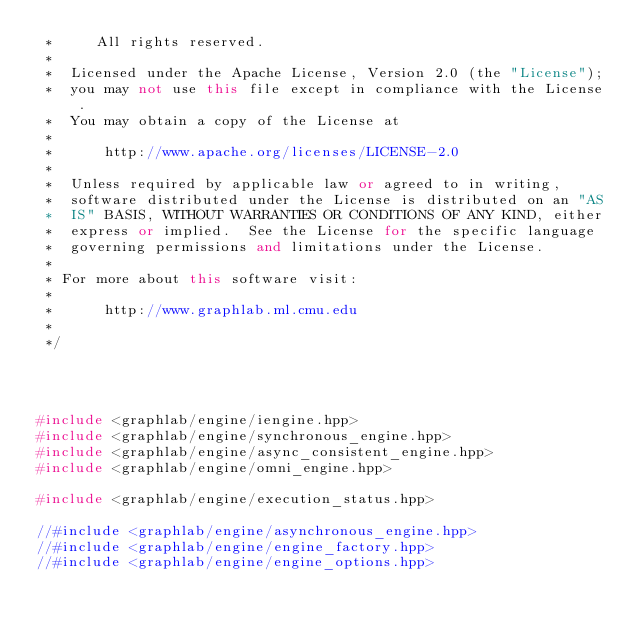<code> <loc_0><loc_0><loc_500><loc_500><_C++_> *     All rights reserved.
 *
 *  Licensed under the Apache License, Version 2.0 (the "License");
 *  you may not use this file except in compliance with the License.
 *  You may obtain a copy of the License at
 *
 *      http://www.apache.org/licenses/LICENSE-2.0
 *
 *  Unless required by applicable law or agreed to in writing,
 *  software distributed under the License is distributed on an "AS
 *  IS" BASIS, WITHOUT WARRANTIES OR CONDITIONS OF ANY KIND, either
 *  express or implied.  See the License for the specific language
 *  governing permissions and limitations under the License.
 *
 * For more about this software visit:
 *
 *      http://www.graphlab.ml.cmu.edu
 *
 */




#include <graphlab/engine/iengine.hpp>
#include <graphlab/engine/synchronous_engine.hpp>
#include <graphlab/engine/async_consistent_engine.hpp>
#include <graphlab/engine/omni_engine.hpp>

#include <graphlab/engine/execution_status.hpp>

//#include <graphlab/engine/asynchronous_engine.hpp>
//#include <graphlab/engine/engine_factory.hpp>
//#include <graphlab/engine/engine_options.hpp>


</code> 